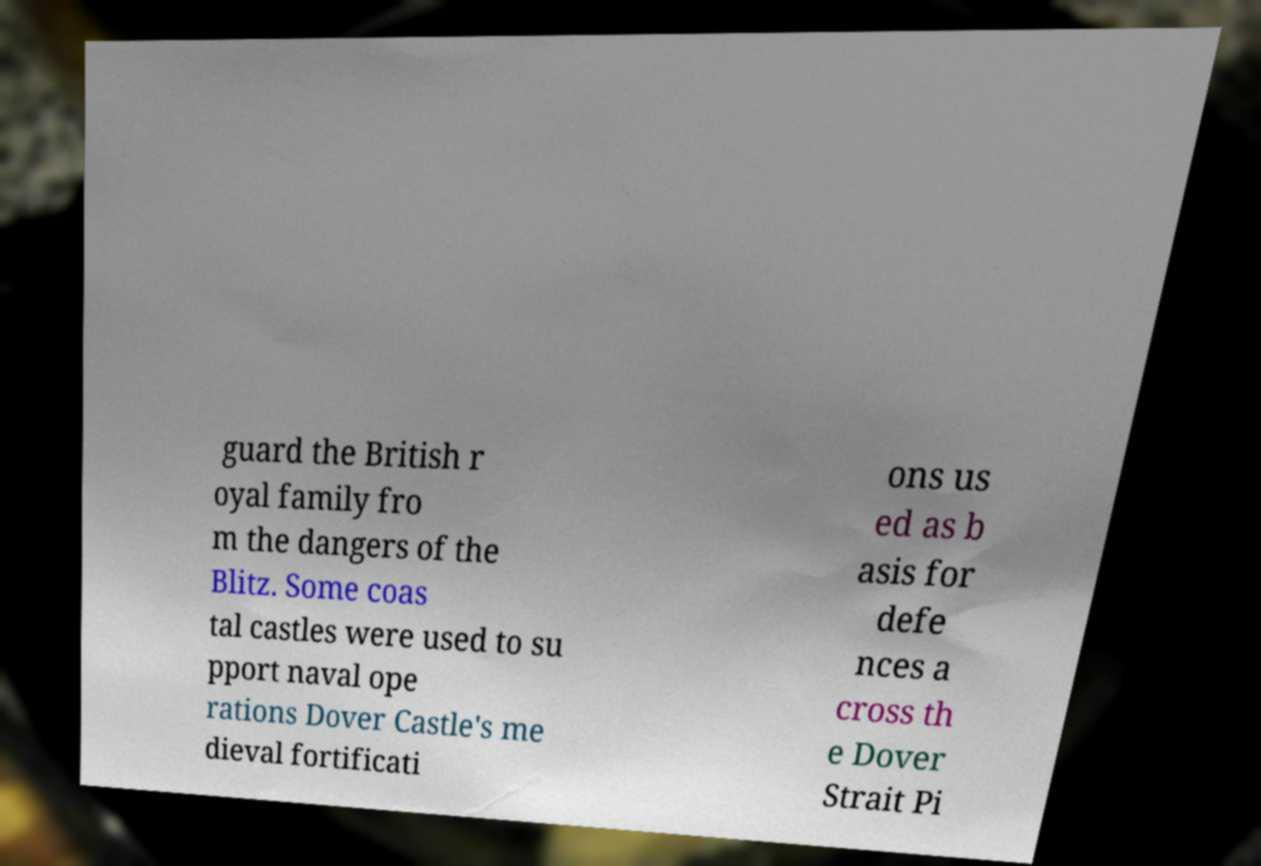Could you extract and type out the text from this image? guard the British r oyal family fro m the dangers of the Blitz. Some coas tal castles were used to su pport naval ope rations Dover Castle's me dieval fortificati ons us ed as b asis for defe nces a cross th e Dover Strait Pi 